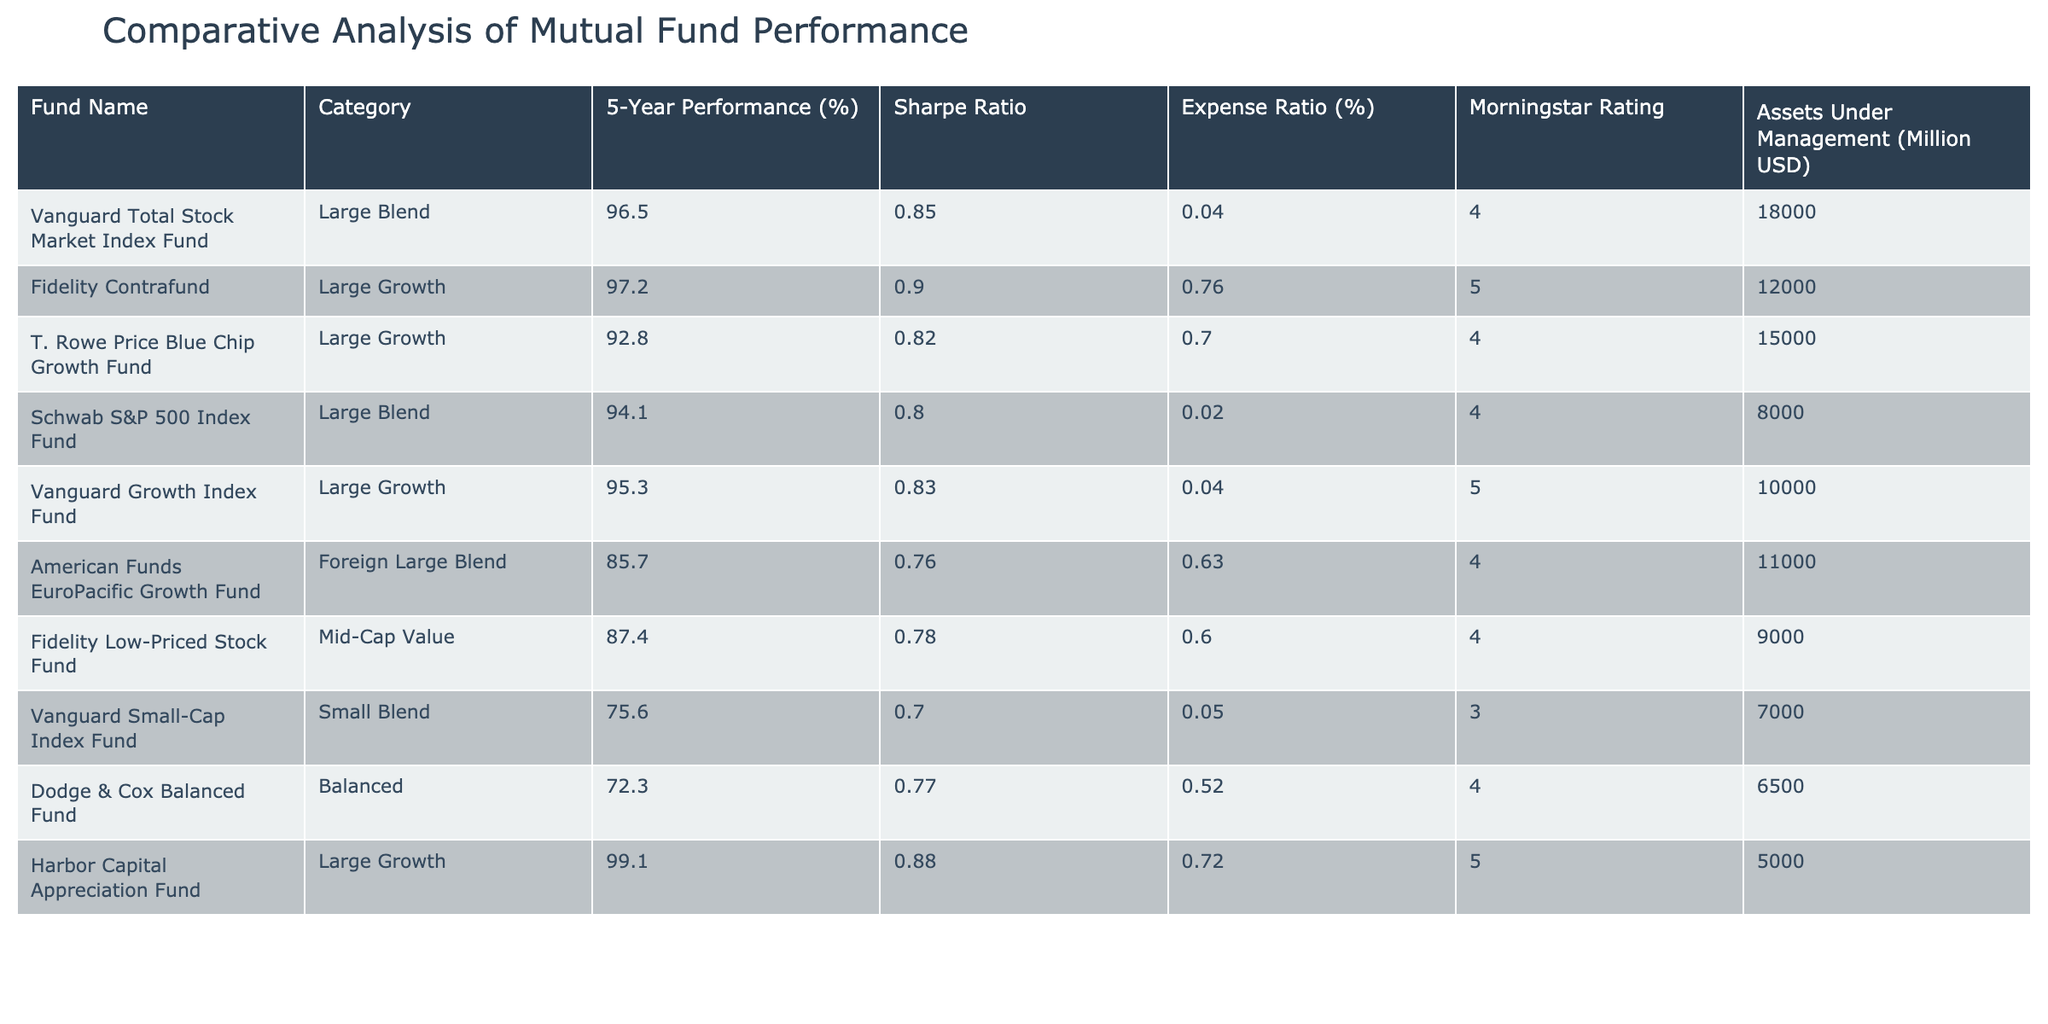What is the 5-Year Performance of the Fidelity Contrafund? The table shows the performance percentages for each mutual fund. Looking at the row for Fidelity Contrafund, the 5-Year Performance is listed as 97.2%.
Answer: 97.2% Which fund has the highest Morningstar Rating? The Morningstar Rating is displayed in the table for each fund. Upon reviewing the ratings, the Fidelity Contrafund and Harbor Capital Appreciation Fund both have a rating of 5, which is the highest.
Answer: Fidelity Contrafund and Harbor Capital Appreciation Fund What is the difference in assets under management between Vanguard Total Stock Market Index Fund and Vanguard Small-Cap Index Fund? The Assets Under Management are shown in millions of USD for each fund. For Vanguard Total Stock Market Index Fund, it's 18000 million, and for Vanguard Small-Cap Index Fund, it's 7000 million. Calculating the difference: 18000 - 7000 = 11000 million.
Answer: 11000 million Is the Sharpe Ratio of the American Funds EuroPacific Growth Fund greater than 0.80? The Sharpe Ratio for American Funds EuroPacific Growth Fund is listed as 0.76. Since 0.76 is less than 0.80, the answer is no.
Answer: No What is the average Expense Ratio (%) of all funds listed in the table? The Expense Ratios are 0.04, 0.76, 0.70, 0.02, 0.04, 0.63, 0.60, 0.05, 0.52, and 0.72. To find the average, we sum these values (0.04 + 0.76 + 0.70 + 0.02 + 0.04 + 0.63 + 0.60 + 0.05 + 0.52 + 0.72 = 3.38) and then divide by the number of funds (10). 3.38 / 10 = 0.338%.
Answer: 0.338% Which category has the lowest 5-Year Performance? By looking at the 5-Year Performance for each fund in the table, the Vanguard Small-Cap Index Fund under the Small Blend category has the lowest performance at 75.6%.
Answer: Small Blend 